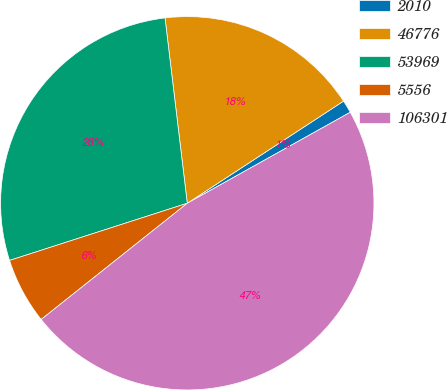Convert chart. <chart><loc_0><loc_0><loc_500><loc_500><pie_chart><fcel>2010<fcel>46776<fcel>53969<fcel>5556<fcel>106301<nl><fcel>1.11%<fcel>17.69%<fcel>28.05%<fcel>5.74%<fcel>47.41%<nl></chart> 